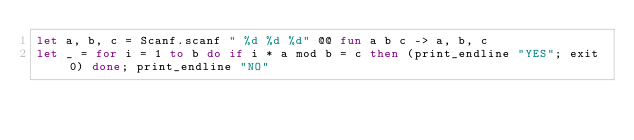<code> <loc_0><loc_0><loc_500><loc_500><_OCaml_>let a, b, c = Scanf.scanf " %d %d %d" @@ fun a b c -> a, b, c
let _ = for i = 1 to b do if i * a mod b = c then (print_endline "YES"; exit 0) done; print_endline "NO"</code> 